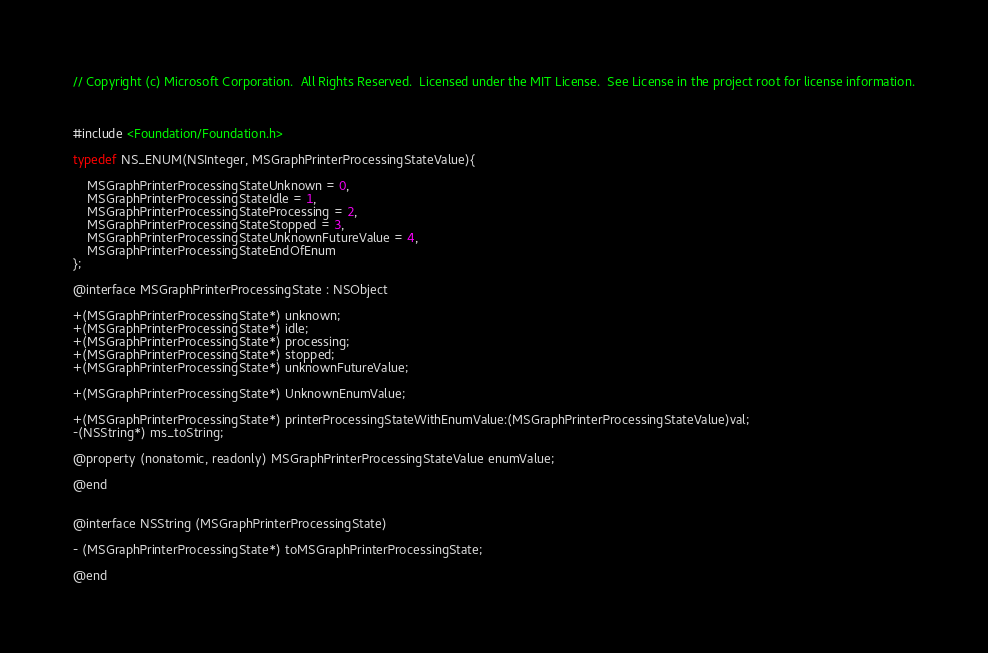<code> <loc_0><loc_0><loc_500><loc_500><_C_>// Copyright (c) Microsoft Corporation.  All Rights Reserved.  Licensed under the MIT License.  See License in the project root for license information.



#include <Foundation/Foundation.h>

typedef NS_ENUM(NSInteger, MSGraphPrinterProcessingStateValue){

	MSGraphPrinterProcessingStateUnknown = 0,
	MSGraphPrinterProcessingStateIdle = 1,
	MSGraphPrinterProcessingStateProcessing = 2,
	MSGraphPrinterProcessingStateStopped = 3,
	MSGraphPrinterProcessingStateUnknownFutureValue = 4,
    MSGraphPrinterProcessingStateEndOfEnum
};

@interface MSGraphPrinterProcessingState : NSObject

+(MSGraphPrinterProcessingState*) unknown;
+(MSGraphPrinterProcessingState*) idle;
+(MSGraphPrinterProcessingState*) processing;
+(MSGraphPrinterProcessingState*) stopped;
+(MSGraphPrinterProcessingState*) unknownFutureValue;

+(MSGraphPrinterProcessingState*) UnknownEnumValue;

+(MSGraphPrinterProcessingState*) printerProcessingStateWithEnumValue:(MSGraphPrinterProcessingStateValue)val;
-(NSString*) ms_toString;

@property (nonatomic, readonly) MSGraphPrinterProcessingStateValue enumValue;

@end


@interface NSString (MSGraphPrinterProcessingState)

- (MSGraphPrinterProcessingState*) toMSGraphPrinterProcessingState;

@end
</code> 